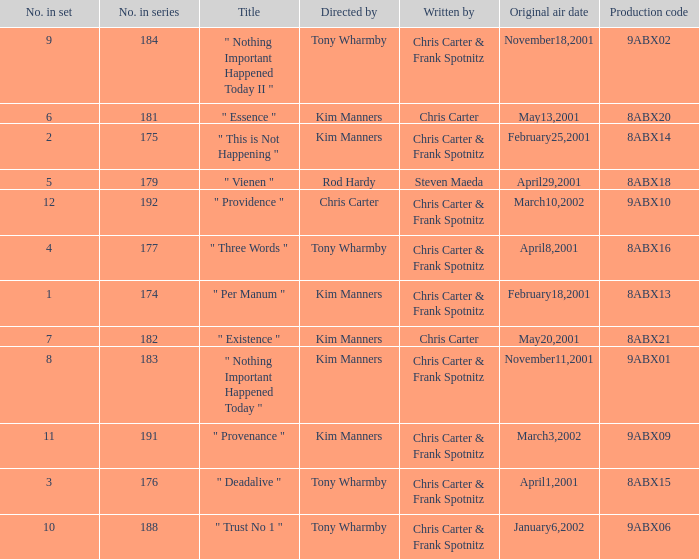The episode with production code 9abx02 was originally aired on what date? November18,2001. 